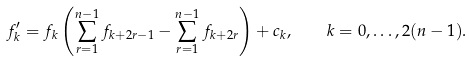<formula> <loc_0><loc_0><loc_500><loc_500>f _ { k } ^ { \prime } = f _ { k } \left ( \sum _ { r = 1 } ^ { n - 1 } f _ { k + 2 r - 1 } - \sum _ { r = 1 } ^ { n - 1 } f _ { k + 2 r } \right ) + c _ { k } , \quad k = 0 , \dots , 2 ( n - 1 ) .</formula> 